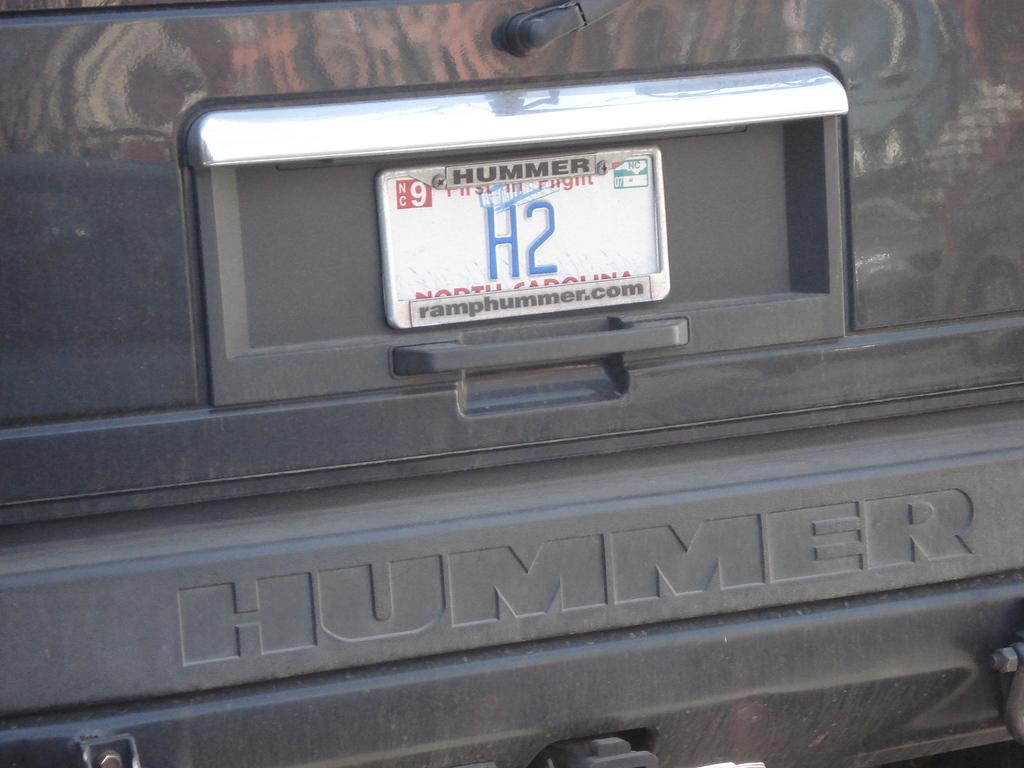<image>
Share a concise interpretation of the image provided. a license plate with H2 written on the back 